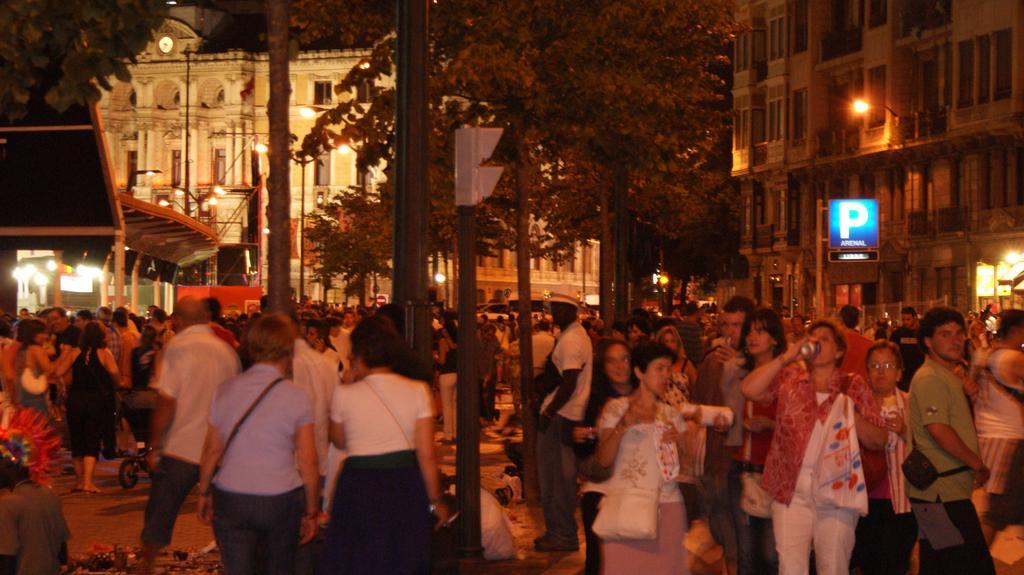Can you describe this image briefly? In the picture I can see a group of people are standing on the ground among them some are wearing bags and some are holding objects in hands. In the background I can see buildings, street lights, trees, poles, vehicles and some other objects. 